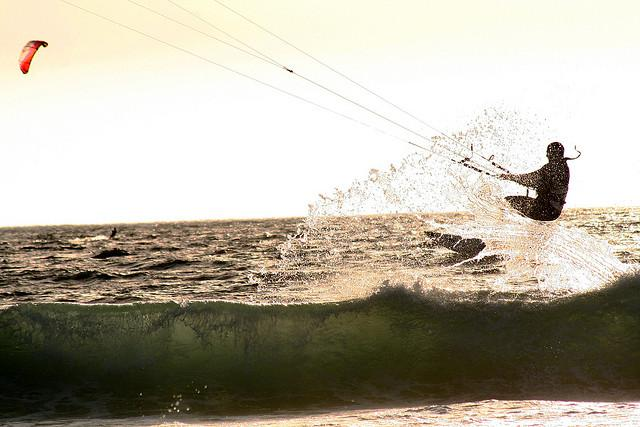The canopy wing is used for?

Choices:
A) kiting
B) surfing
C) parasailing
D) swimming parasailing 